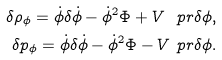<formula> <loc_0><loc_0><loc_500><loc_500>\delta \rho _ { \phi } = \dot { \phi } \delta \dot { \phi } - \dot { \phi } ^ { 2 } \Phi + V ^ { \ } p r \delta \phi , \\ \delta p _ { \phi } = \dot { \phi } \delta \dot { \phi } - \dot { \phi } ^ { 2 } \Phi - V ^ { \ } p r \delta \phi .</formula> 